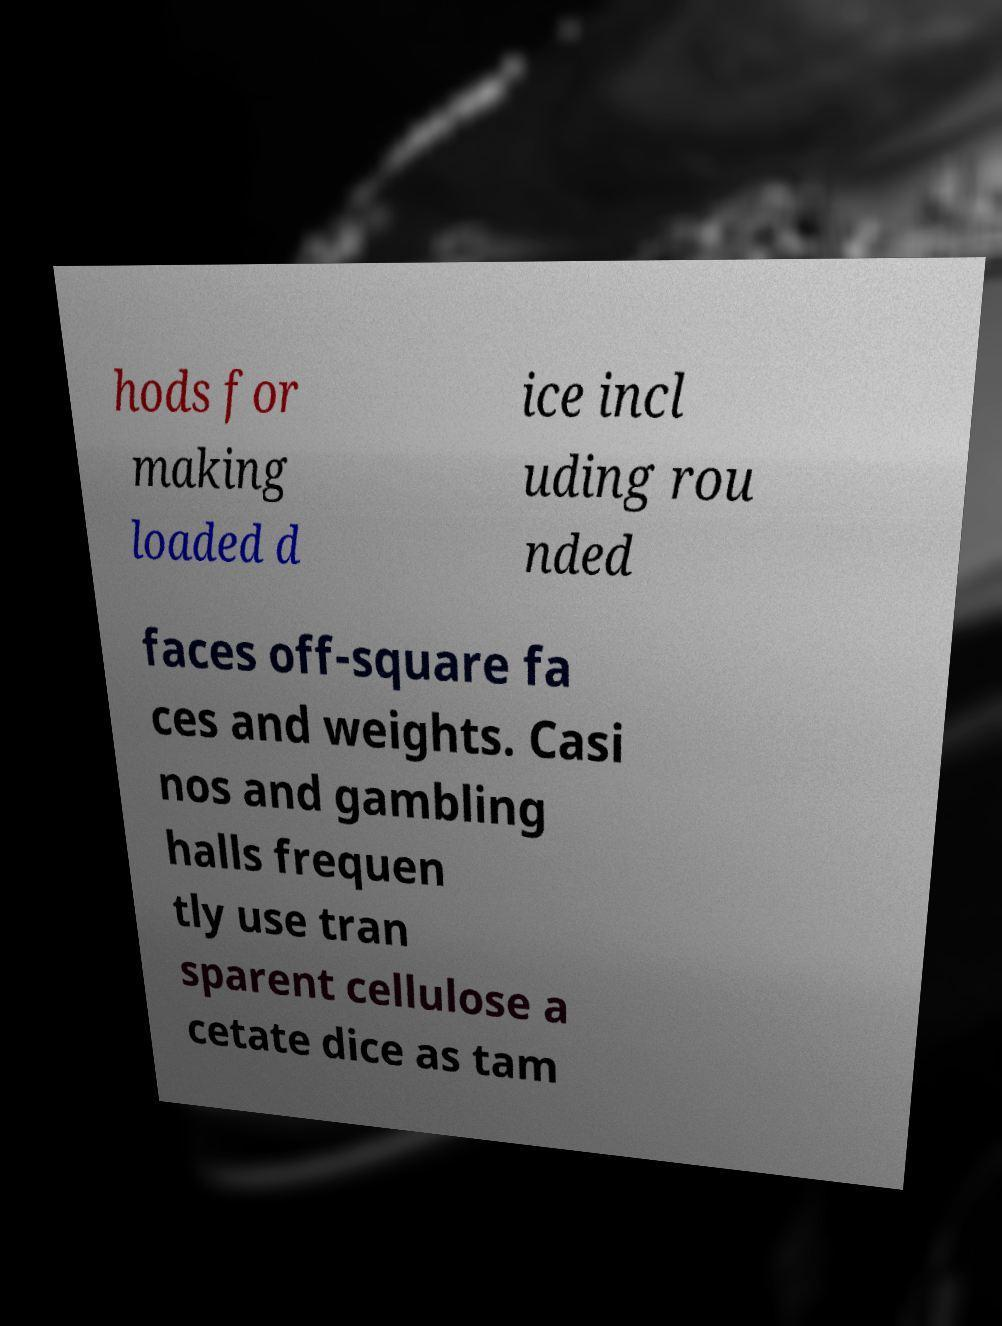Please identify and transcribe the text found in this image. hods for making loaded d ice incl uding rou nded faces off-square fa ces and weights. Casi nos and gambling halls frequen tly use tran sparent cellulose a cetate dice as tam 